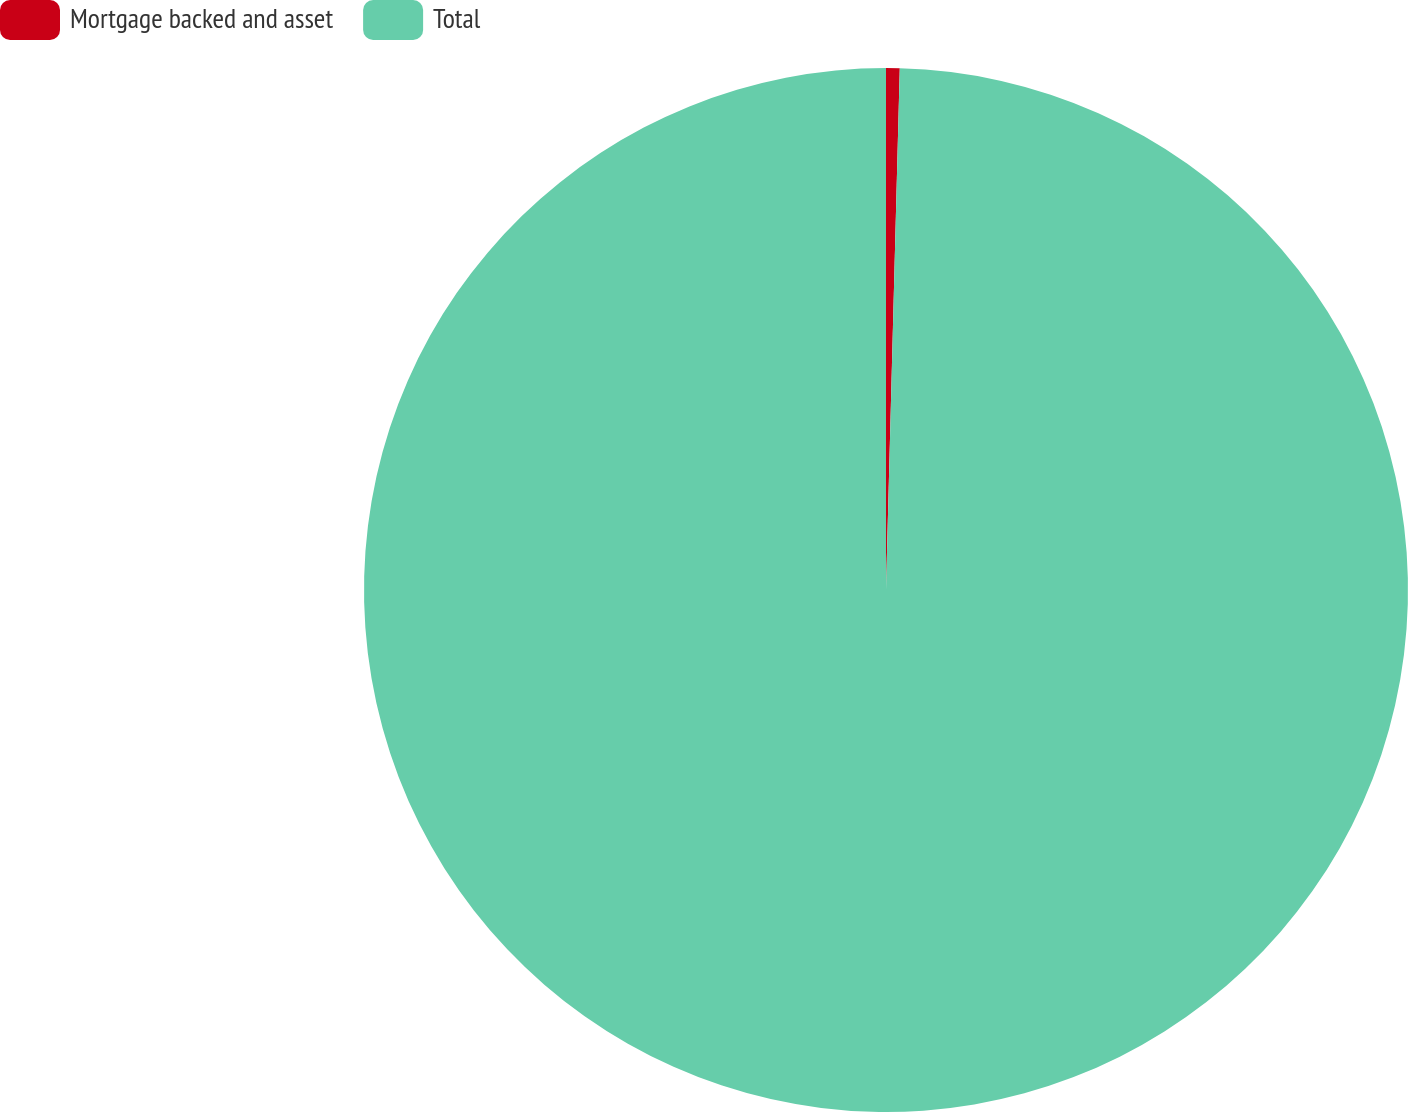Convert chart. <chart><loc_0><loc_0><loc_500><loc_500><pie_chart><fcel>Mortgage backed and asset<fcel>Total<nl><fcel>0.42%<fcel>99.58%<nl></chart> 